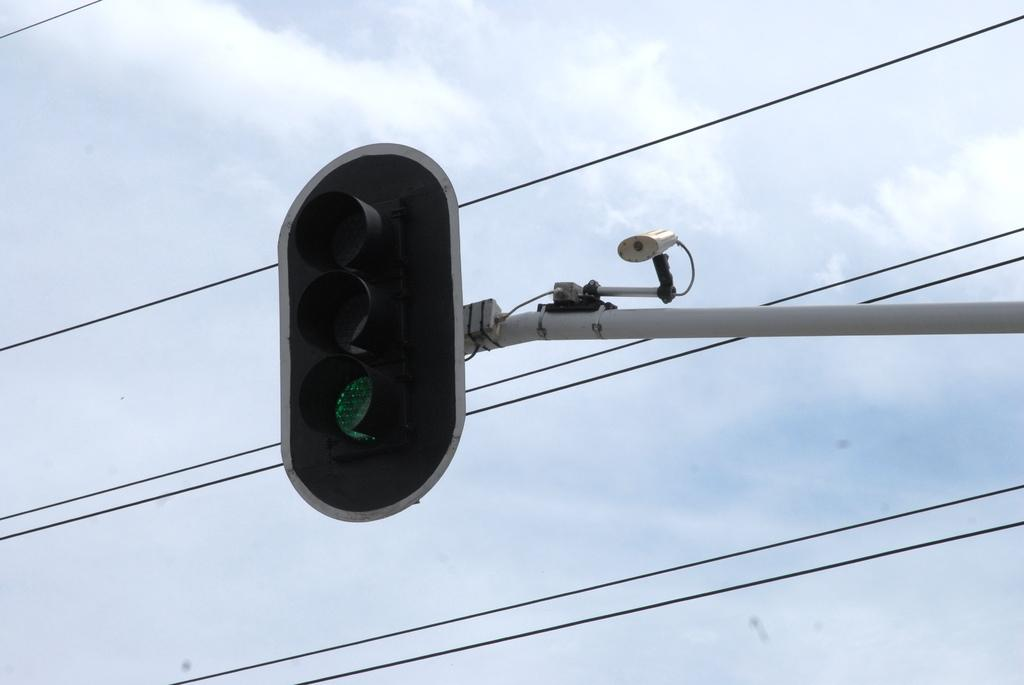What is the main object in the image? There is a traffic light in the image. Is there anything attached to the traffic light pole? Yes, a camera is attached to the pole. What else can be seen in the image besides the traffic light and camera? There are wires visible in the image. What is visible in the background of the image? The sky is visible in the image. What type of trousers is the plantation owner wearing in the image? There is no plantation owner or trousers present in the image; it features a traffic light and a camera attached to a pole. 